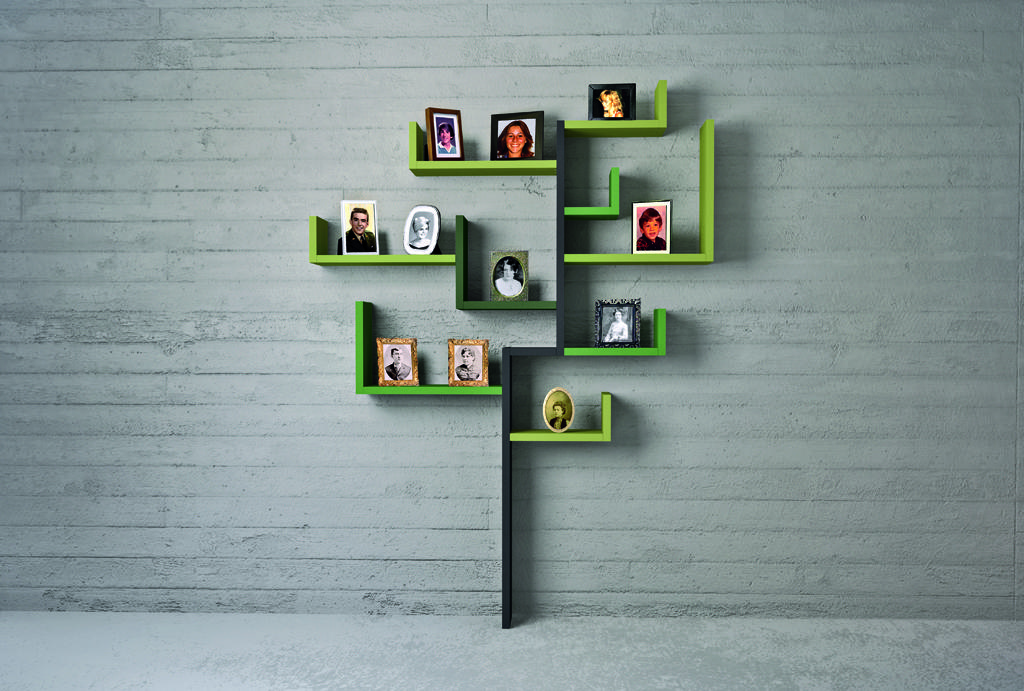What type of furniture is present in the image? There are decorative shelves in the image. How are the shelves positioned in the image? The shelves are attached to a wall. What can be seen on the shelves? There are many photo frames on the shelves. What type of fruit is the squirrel holding in the image? There is no squirrel or fruit present in the image. What is the price of the photo frames on the shelves? The provided facts do not mention any prices, so it cannot be determined from the image. 